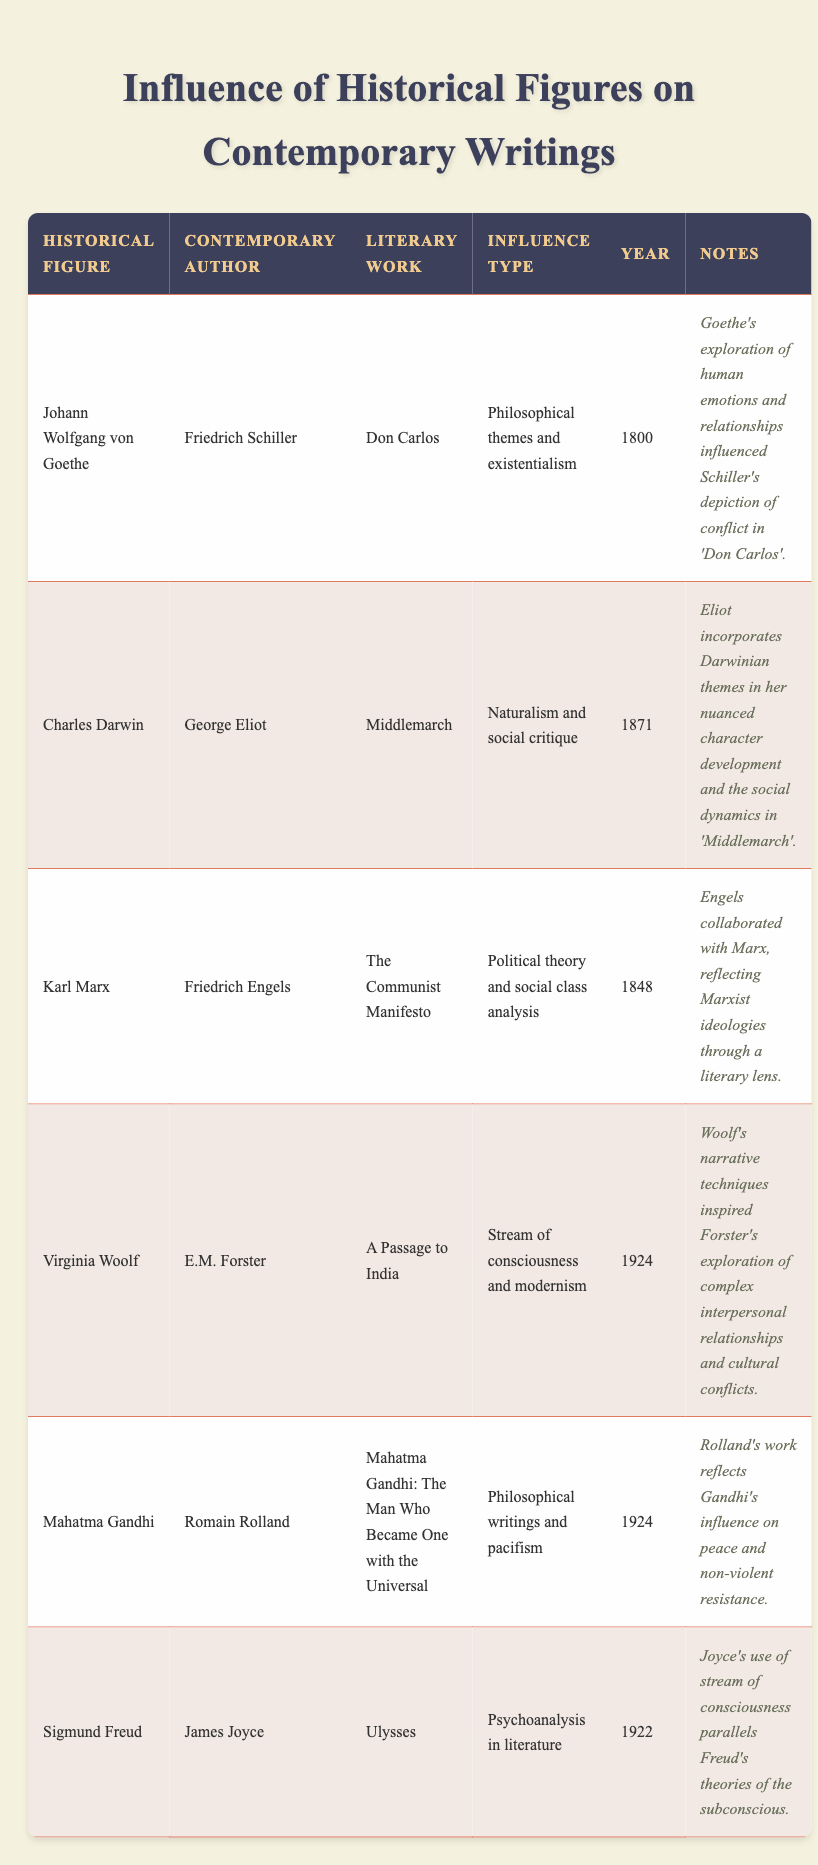What influence type is associated with Goethe and Schiller? Go to the row where Goethe is listed and look for the corresponding influence type. In the table, it states "Philosophical themes and existentialism" as the influence type for Goethe regarding Schiller's work.
Answer: Philosophical themes and existentialism Which contemporary author is linked to Charles Darwin? Locate the row with Charles Darwin and find the name of the contemporary author in that same row. It shows that George Eliot is linked to Darwin.
Answer: George Eliot What year was Virginia Woolf's influence on E.M. Forster noted? In the table, identify the row with Virginia Woolf. The corresponding year in that row is 1924, indicating the time of influence on Forster.
Answer: 1924 Is it true that Freud influenced Joyce's literary work? Check the row with Sigmund Freud and see if there is a mention of influence on Joyce. The table confirms that Freud did influence Joyce's work, making the statement true.
Answer: Yes What is the difference between the years of Marx's and Gandhi's influenced literary works? Look up the years associated with Marx and Gandhi. Marx's work is from 1848, and Gandhi's is from 1924. The difference is 1924 - 1848 = 76 years.
Answer: 76 years Which literary work was influenced by Gandhi and what was its influence type? Find the row for Mahatma Gandhi to identify the associated literary work and its influence type. It shows that Romain Rolland's work, "Mahatma Gandhi: The Man Who Became One with the Universal," reflects Gandhi's influence on philosophical writings and pacifism.
Answer: "Mahatma Gandhi: The Man Who Became One with the Universal"; Philosophical writings and pacifism How many authors are listed in the table who were influenced by their contemporaries in the year 1924? Identify the rows for the year 1924. In the table, both Virginia Woolf and Mahatma Gandhi's works are from this year, indicating that there are 2 authors connected to the year 1924 in this context.
Answer: 2 authors What common influence type do Darwin and Woolf share in their contemporary literary works? Review the influence types for both Darwin and Woolf. Darwin’s work relates to "Naturalism and social critique," and Woolf's is "Stream of consciousness and modernism." Since they focus on different themes, they actually do not share a common influence type.
Answer: No common influence type 